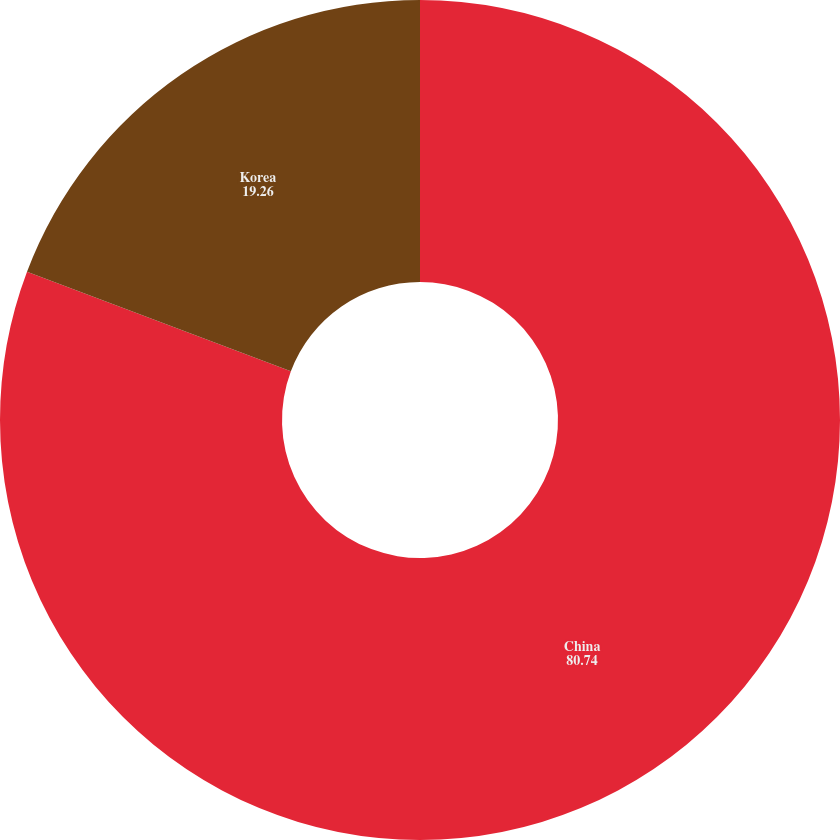Convert chart to OTSL. <chart><loc_0><loc_0><loc_500><loc_500><pie_chart><fcel>China<fcel>Korea<nl><fcel>80.74%<fcel>19.26%<nl></chart> 